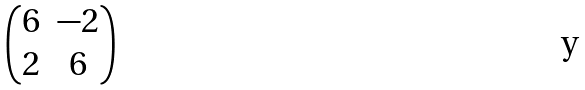<formula> <loc_0><loc_0><loc_500><loc_500>\begin{pmatrix} 6 & - 2 \\ 2 & 6 \\ \end{pmatrix}</formula> 